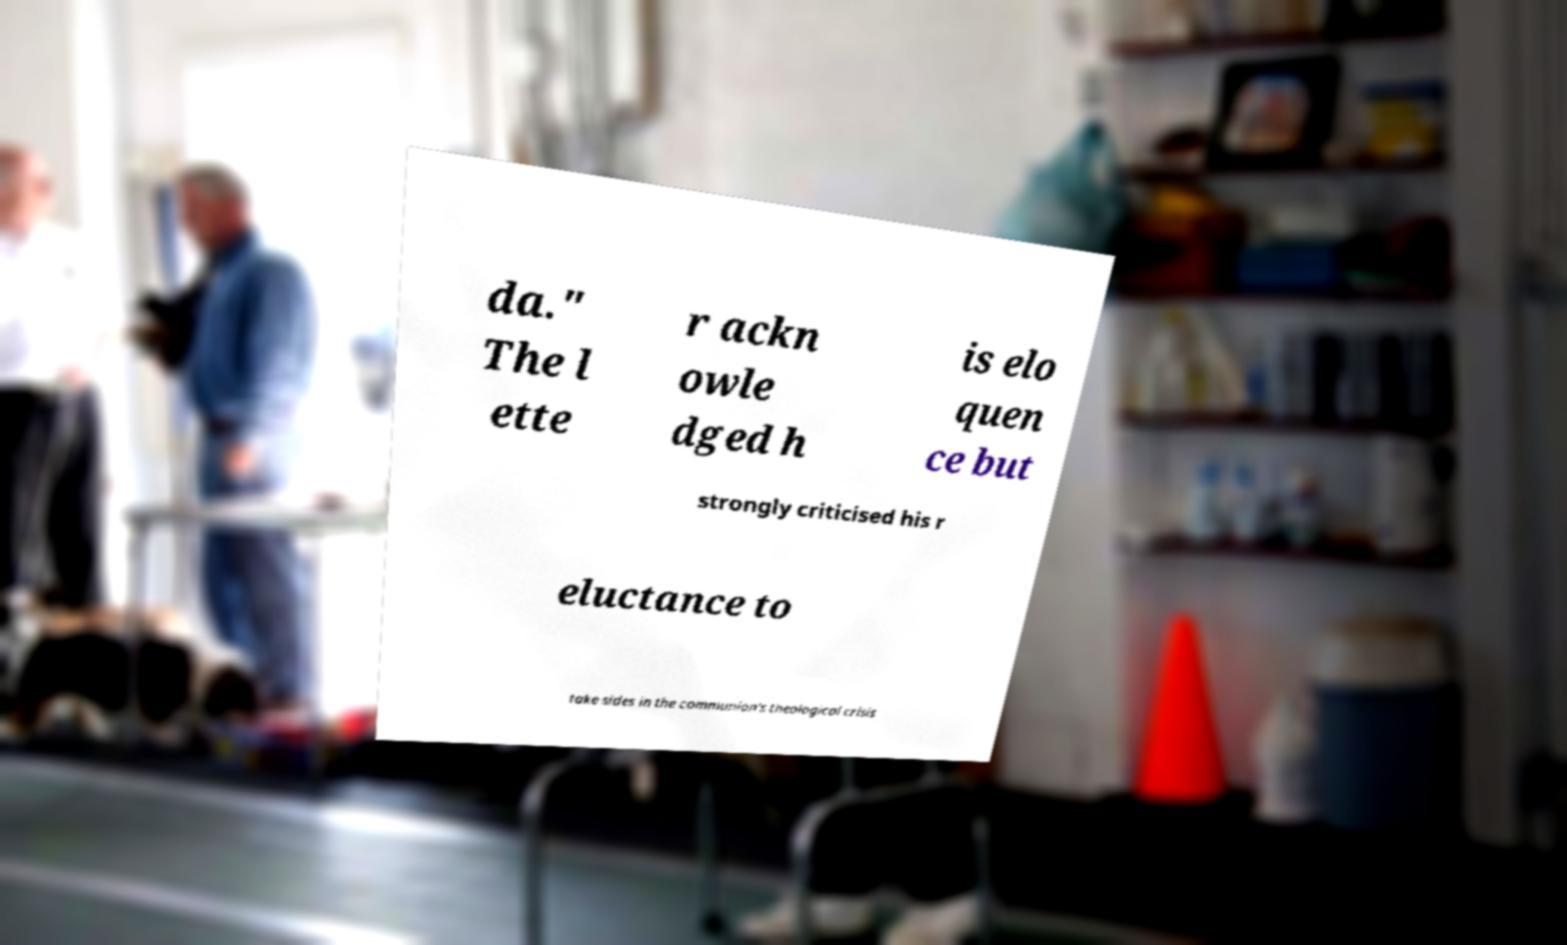Can you accurately transcribe the text from the provided image for me? da." The l ette r ackn owle dged h is elo quen ce but strongly criticised his r eluctance to take sides in the communion's theological crisis 